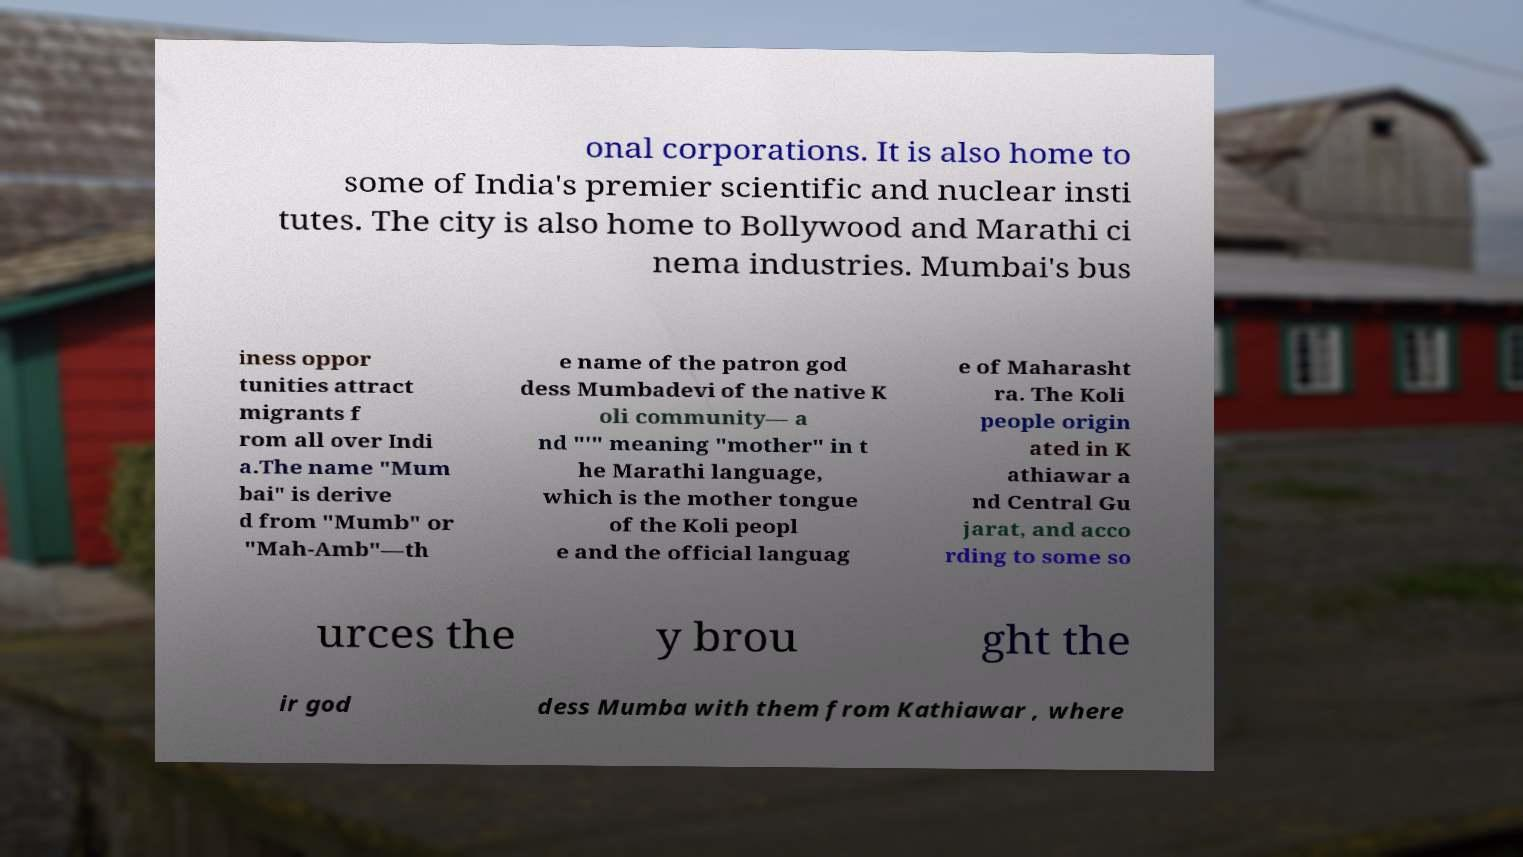Could you assist in decoding the text presented in this image and type it out clearly? onal corporations. It is also home to some of India's premier scientific and nuclear insti tutes. The city is also home to Bollywood and Marathi ci nema industries. Mumbai's bus iness oppor tunities attract migrants f rom all over Indi a.The name "Mum bai" is derive d from "Mumb" or "Mah-Amb"—th e name of the patron god dess Mumbadevi of the native K oli community— a nd "'" meaning "mother" in t he Marathi language, which is the mother tongue of the Koli peopl e and the official languag e of Maharasht ra. The Koli people origin ated in K athiawar a nd Central Gu jarat, and acco rding to some so urces the y brou ght the ir god dess Mumba with them from Kathiawar , where 